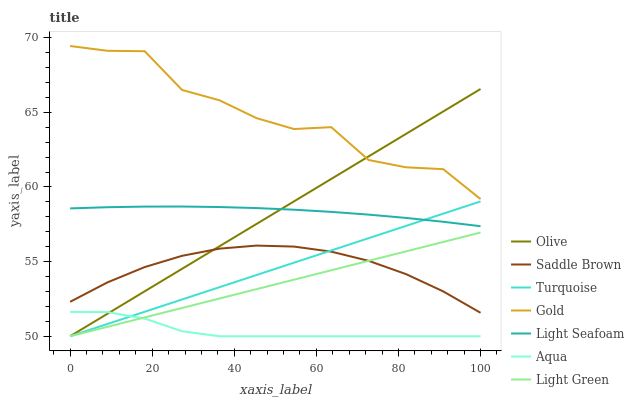Does Aqua have the minimum area under the curve?
Answer yes or no. Yes. Does Gold have the maximum area under the curve?
Answer yes or no. Yes. Does Gold have the minimum area under the curve?
Answer yes or no. No. Does Aqua have the maximum area under the curve?
Answer yes or no. No. Is Olive the smoothest?
Answer yes or no. Yes. Is Gold the roughest?
Answer yes or no. Yes. Is Aqua the smoothest?
Answer yes or no. No. Is Aqua the roughest?
Answer yes or no. No. Does Turquoise have the lowest value?
Answer yes or no. Yes. Does Gold have the lowest value?
Answer yes or no. No. Does Gold have the highest value?
Answer yes or no. Yes. Does Aqua have the highest value?
Answer yes or no. No. Is Turquoise less than Gold?
Answer yes or no. Yes. Is Gold greater than Saddle Brown?
Answer yes or no. Yes. Does Saddle Brown intersect Turquoise?
Answer yes or no. Yes. Is Saddle Brown less than Turquoise?
Answer yes or no. No. Is Saddle Brown greater than Turquoise?
Answer yes or no. No. Does Turquoise intersect Gold?
Answer yes or no. No. 